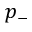<formula> <loc_0><loc_0><loc_500><loc_500>p _ { - }</formula> 